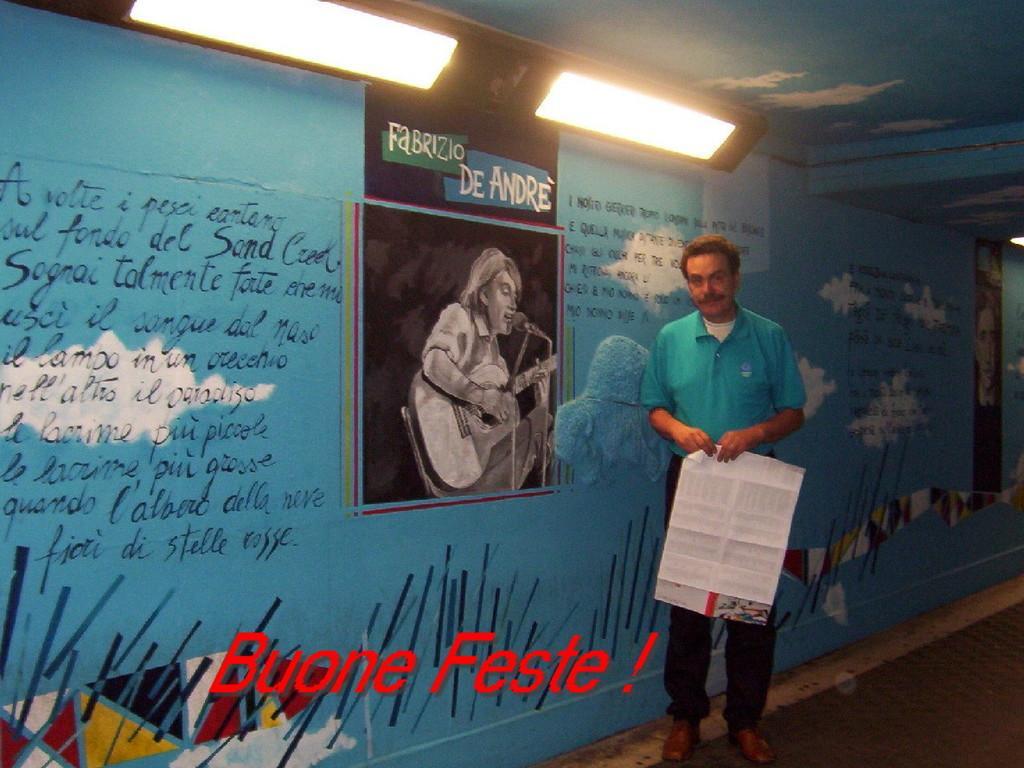How would you summarize this image in a sentence or two? In the picture we can see a person wearing blue color T-shirt is holding a paper and standing near the wall. In the background, we can see a blue color wall on which we can see some text is painted and we can see a picture of a person holding a guitar and there is a mic in front. Here we can see the ceiling lights and a watermark at the bottom of the image. 